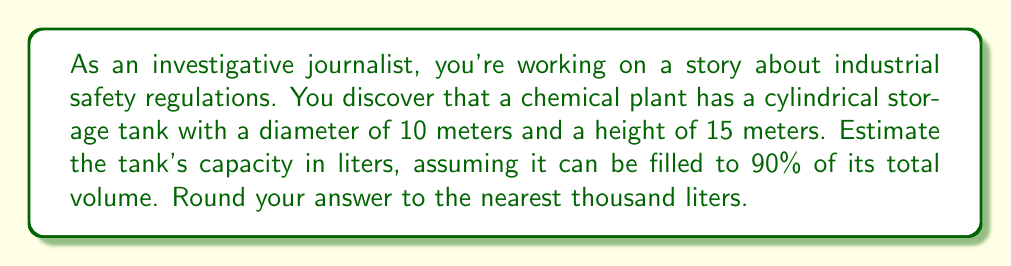Can you answer this question? Let's approach this step-by-step:

1) First, we need to calculate the volume of the cylindrical tank. The formula for the volume of a cylinder is:

   $$V = \pi r^2 h$$

   where $r$ is the radius and $h$ is the height.

2) We're given the diameter (10 meters), so the radius is half of that:
   
   $$r = 5 \text{ meters}$$

3) Now we can plug in our values:

   $$V = \pi (5\text{ m})^2 (15\text{ m}) = 375\pi \text{ m}^3$$

4) Let's calculate this:

   $$V \approx 1,178.10 \text{ m}^3$$

5) However, we're told the tank can only be filled to 90% of its capacity:

   $$\text{Usable volume} = 1,178.10 \text{ m}^3 \times 0.90 = 1,060.29 \text{ m}^3$$

6) We need to convert this to liters. There are 1000 liters in a cubic meter:

   $$1,060.29 \text{ m}^3 \times 1000 \text{ L/m}^3 = 1,060,290 \text{ L}$$

7) Rounding to the nearest thousand liters:

   $$1,060,290 \text{ L} \approx 1,060,000 \text{ L}$$
Answer: 1,060,000 L 